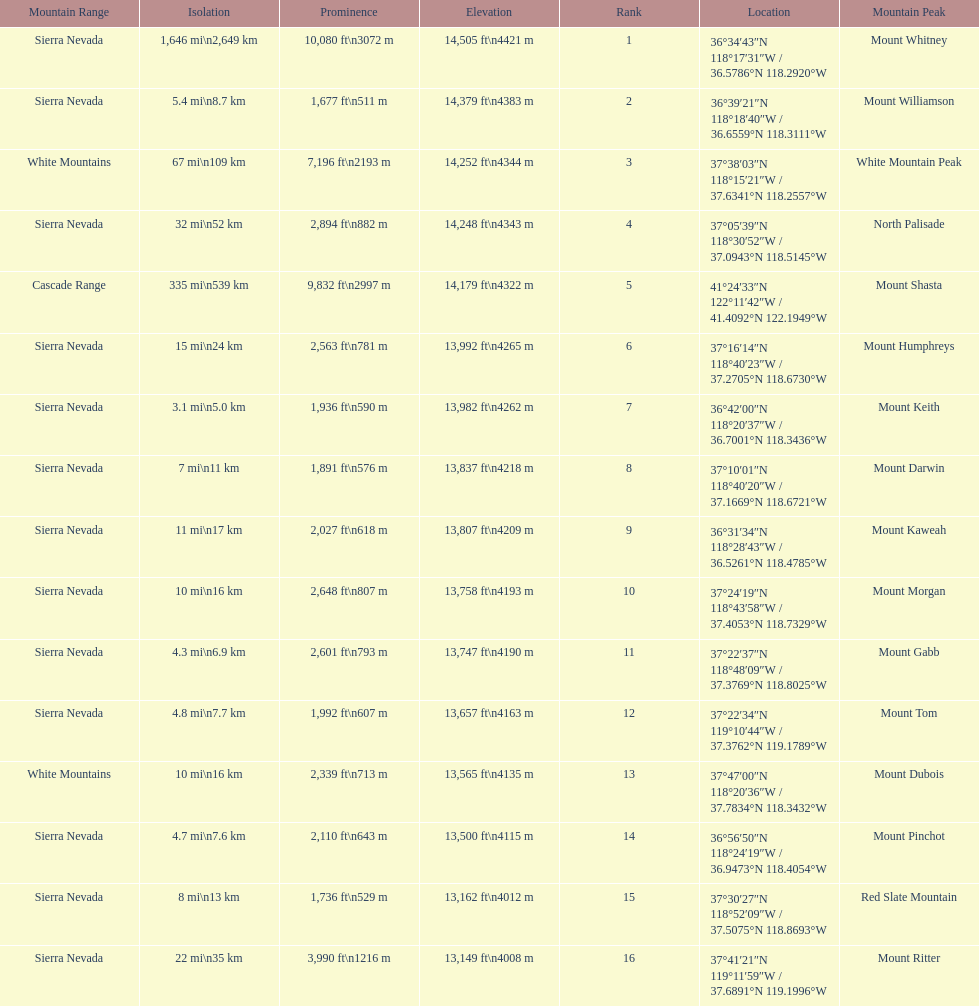How much taller is the mountain peak of mount williamson than that of mount keith? 397 ft. 